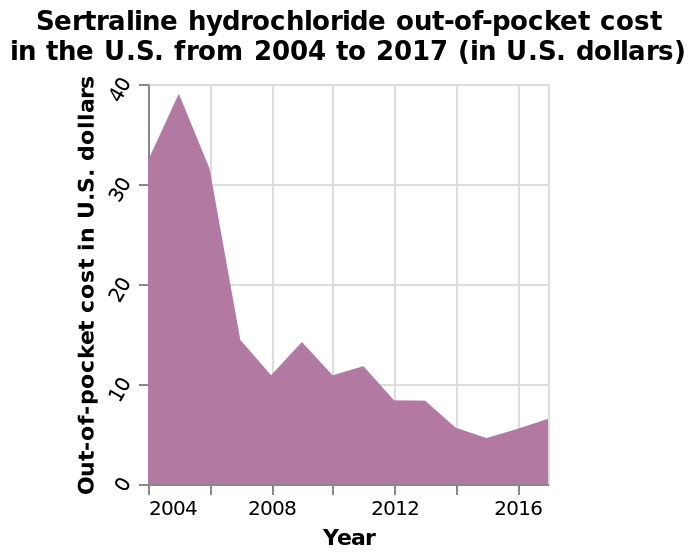<image>
Offer a thorough analysis of the image. The cost decreased over 12 years. There was a spike in the cost in 2004. Did the cost increase or decrease over the 12-year period?  The cost decreased over the 12-year period. How much did the cost spike in 2004?  The exact amount of the spike in cost in 2004 is not mentioned in the description. 